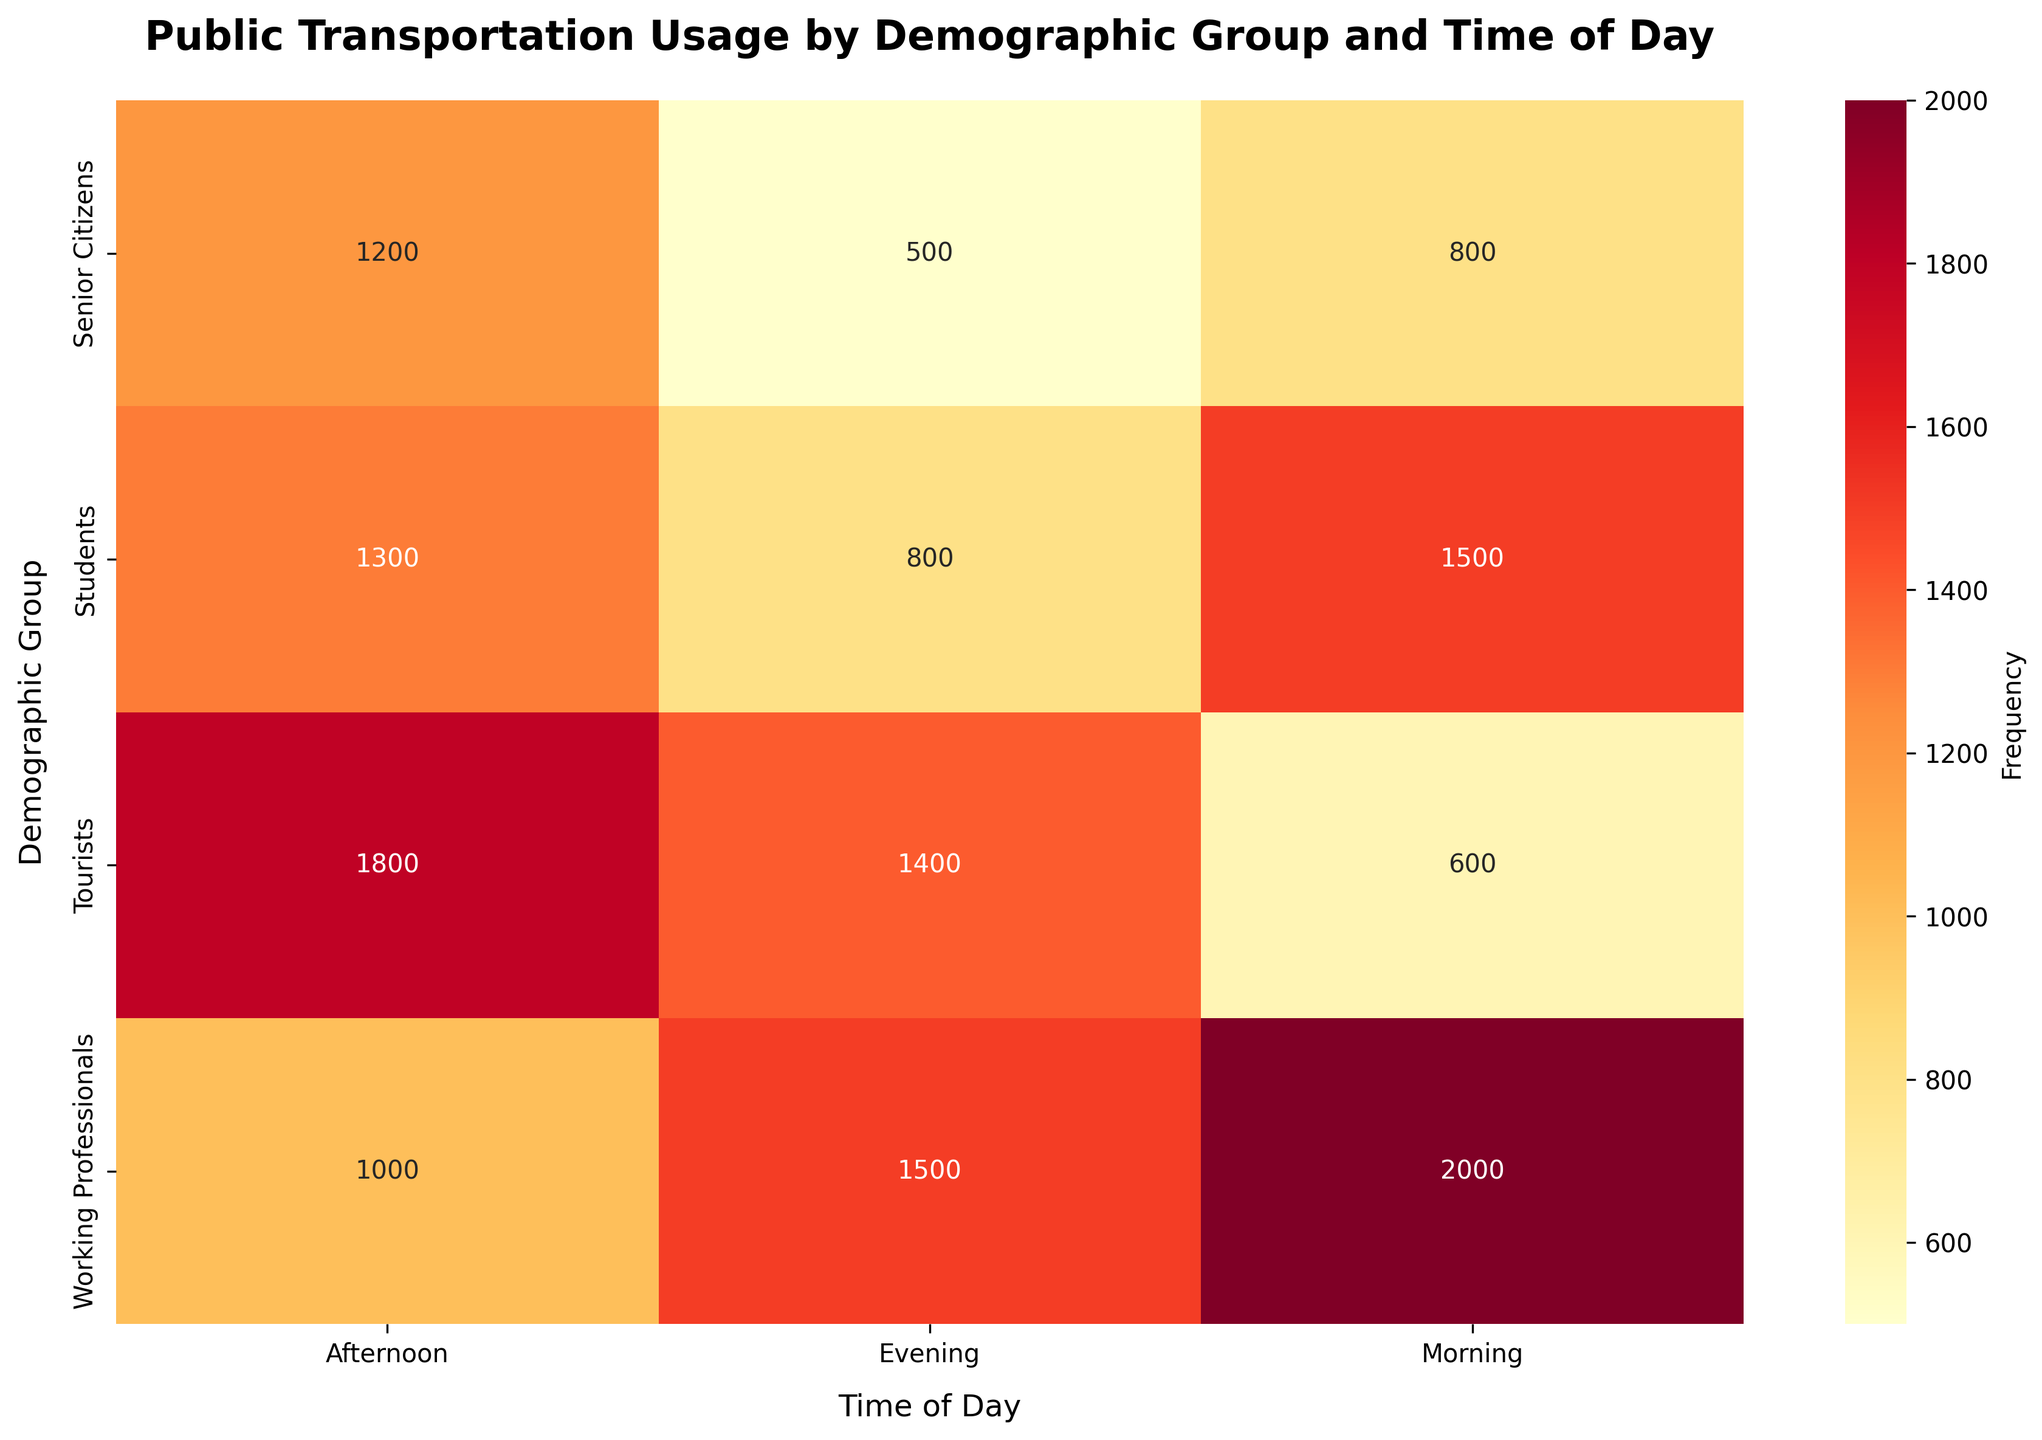What is the highest frequency value on the heatmap? The highest value is seen in the "Working Professionals" group for the "Morning" time of day. This can be identified by looking at the cell with the darkest shade of the color scale in the heatmap.
Answer: 2000 Which demographic group uses public transportation the least in the evening? To find the lowest value in the "Evening" column, compare the frequencies for each group in that time of day. The "Senior Citizens" group has the lowest frequency in the evening.
Answer: Senior Citizens Which time of day has the highest combined usage for Working Professionals? Sum the values for "Working Professionals" in the "Morning," "Afternoon," and "Evening" columns. Compare these totals to find the highest combined usage time. Morning: 2000, Afternoon: 1000, Evening: 1500. The "Morning" time has the highest total.
Answer: Morning Which time of day shows the least variation in usage between the different demographic groups? Calculate the difference between the maximum and minimum frequency values for each time of day. Morning: 2000-600=1400, Afternoon: 1800-1000=800, Evening: 1500-500=1000. The "Afternoon" has the least variation.
Answer: Afternoon What is the proportion of morning usage between Working Professionals and Students? Find the frequency values for both groups in the "Morning" column. Divide the value for Working Professionals by the value for Students. 2000 (Working Professionals) / 1500 (Students) = 4/3 or 1.33
Answer: 1.33 Which demographic group has the most even distribution of usage across all times of day? Calculate the standard deviation of the frequencies for each demographic group. The group with the lowest standard deviation has the most even distribution. Students: SD=295.8, Working Professionals: SD=500, Senior Citizens: SD=305.5, Tourists: SD=643.6.
Answer: Students 